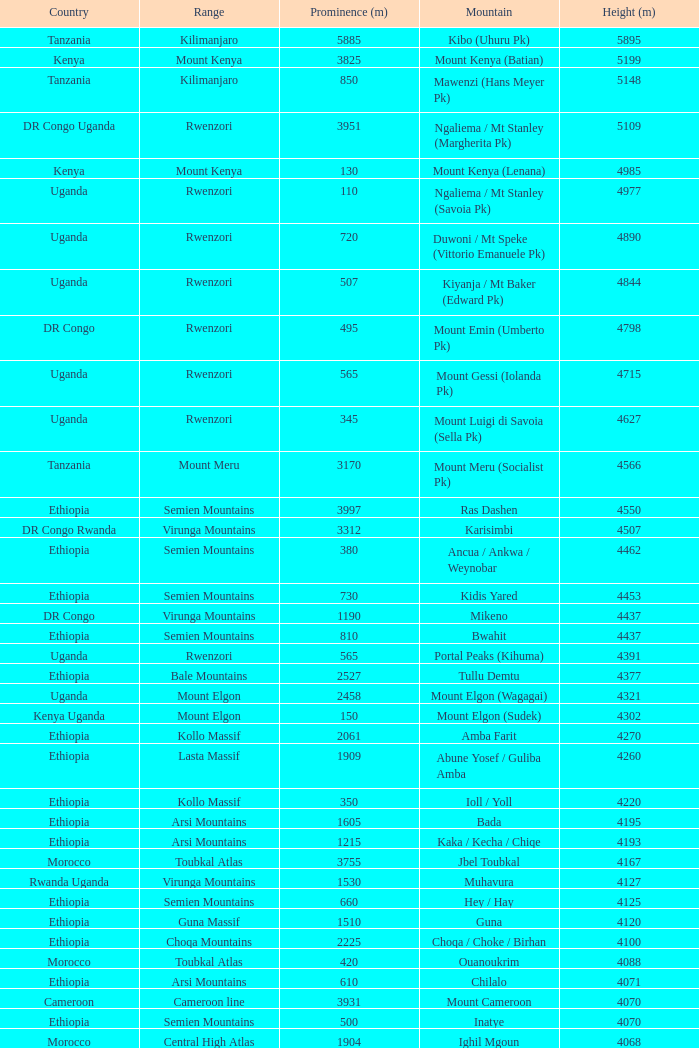How tall is the Mountain of jbel ghat? 1.0. 